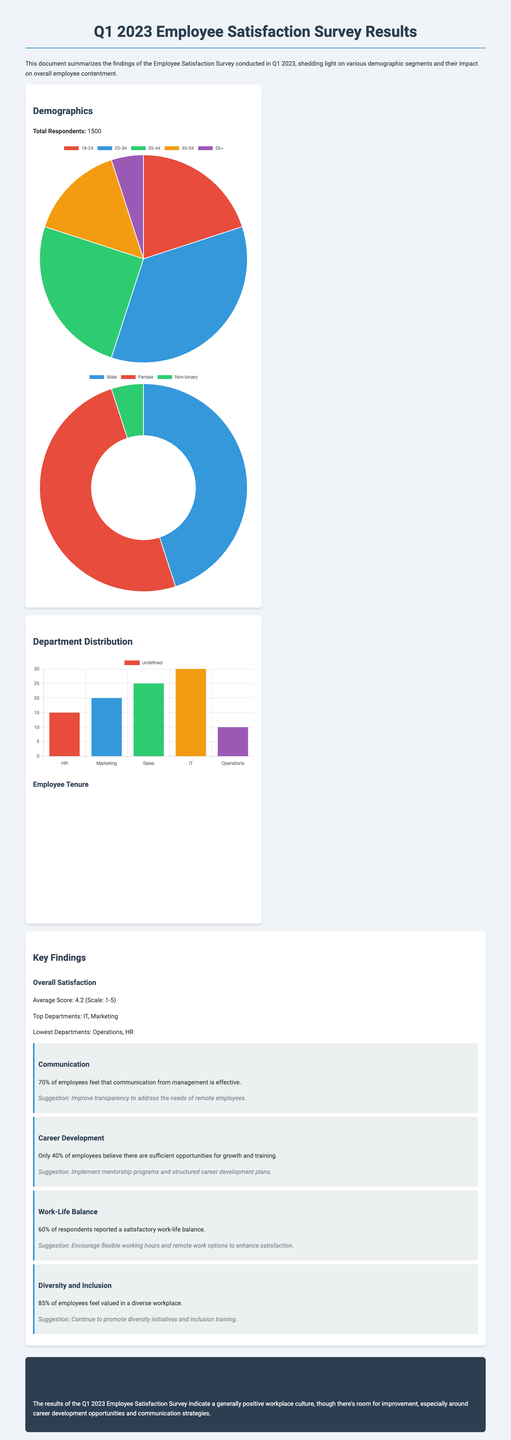What is the total number of respondents? The total number of respondents is listed in the demographics section of the document as 1500.
Answer: 1500 What percentage of employees feel that communication from management is effective? The document states that 70% of employees feel that communication from management is effective.
Answer: 70% Which two departments had the highest satisfaction scores? The document mentions that the top departments in terms of satisfaction are IT and Marketing.
Answer: IT, Marketing What is the average satisfaction score recorded in the survey? The average satisfaction score provided in the document is 4.2 on a scale of 1 to 5.
Answer: 4.2 What suggestion is given to improve career development? The document suggests implementing mentorship programs and structured career development plans to improve career development.
Answer: Implement mentorship programs and structured career development plans How many employees reported a satisfactory work-life balance? According to the findings, 60% of respondents reported a satisfactory work-life balance.
Answer: 60% In the gender distribution chart, what percentage of respondents identified as female? The gender distribution chart indicates that 50% of respondents identified as female.
Answer: 50% What is indicated as a suggestion for enhancing diversity and inclusion? The document suggests continuing to promote diversity initiatives and inclusion training to enhance diversity and inclusion.
Answer: Continue to promote diversity initiatives and inclusion training 